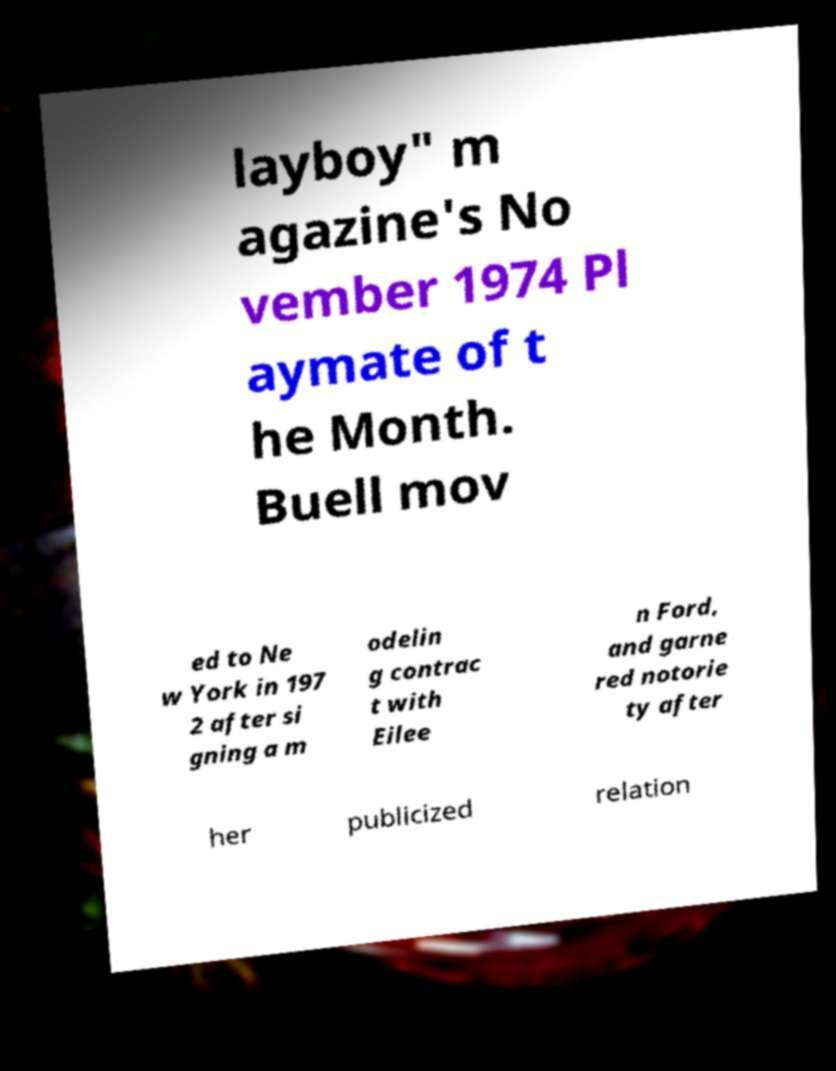I need the written content from this picture converted into text. Can you do that? layboy" m agazine's No vember 1974 Pl aymate of t he Month. Buell mov ed to Ne w York in 197 2 after si gning a m odelin g contrac t with Eilee n Ford, and garne red notorie ty after her publicized relation 